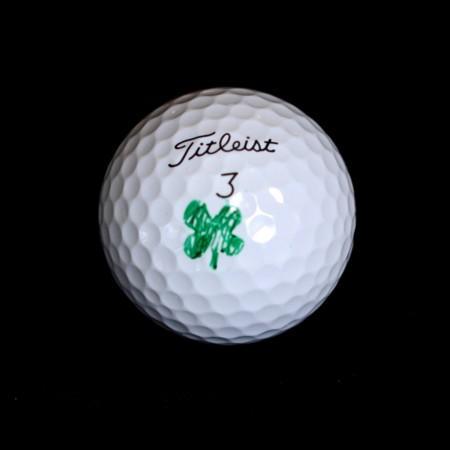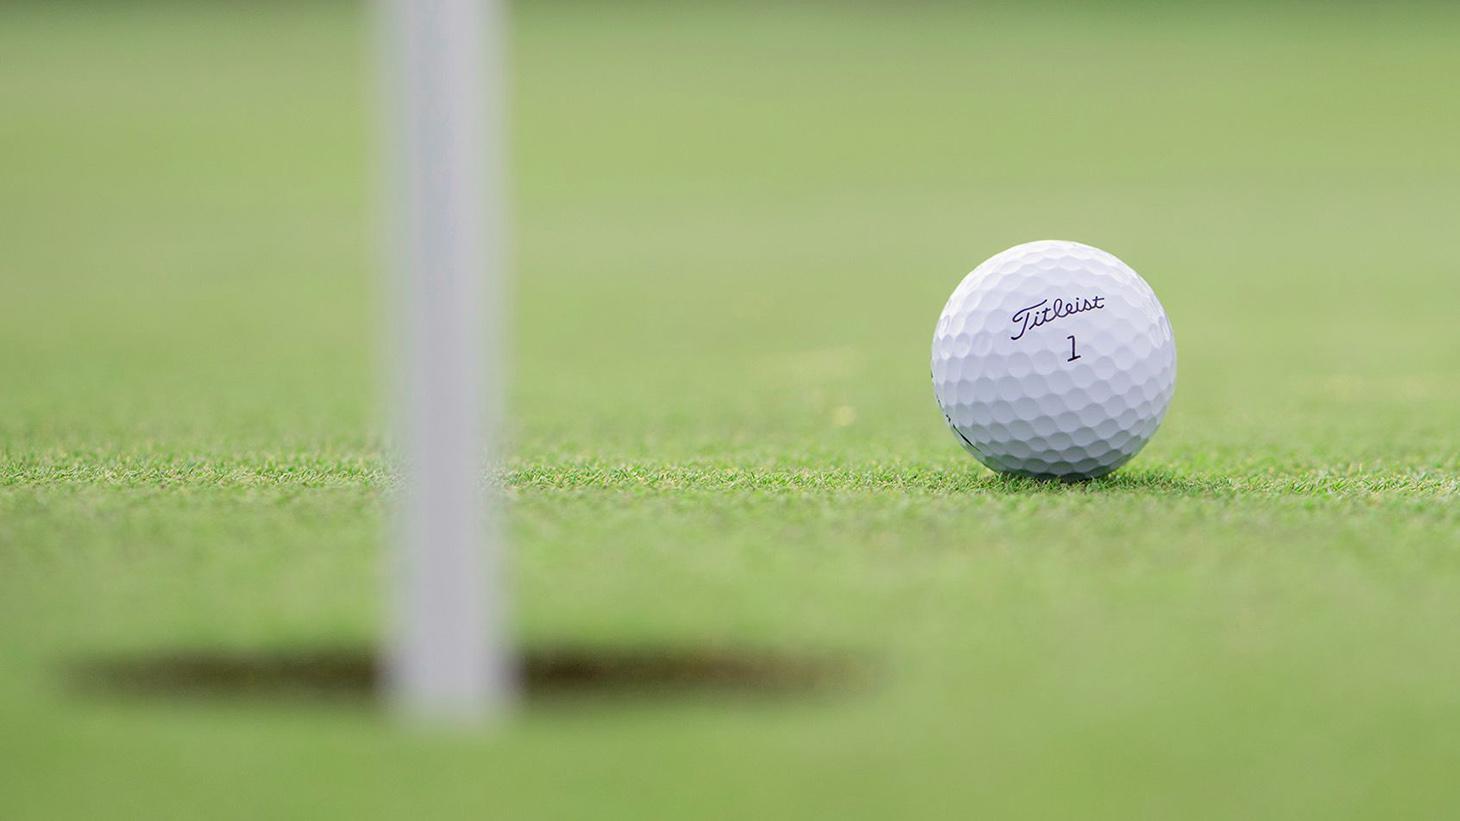The first image is the image on the left, the second image is the image on the right. Considering the images on both sides, is "The ball in the image on the right is sitting on a white tee." valid? Answer yes or no. No. The first image is the image on the left, the second image is the image on the right. Examine the images to the left and right. Is the description "Right image shows one white golf ball perched on a tee." accurate? Answer yes or no. No. 